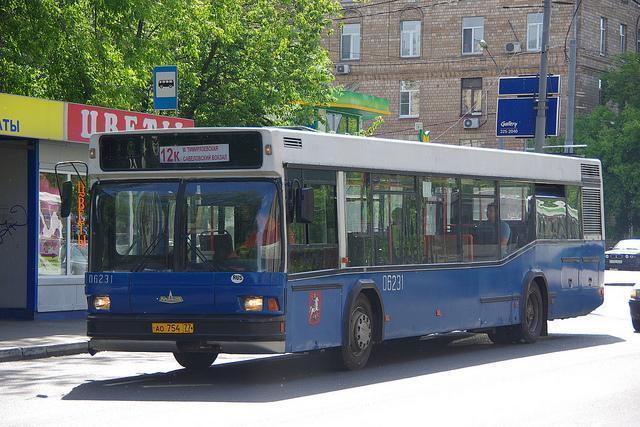How many wheels can you see on the bus?
Give a very brief answer. 4. How many buses are there?
Give a very brief answer. 1. How many tents in this image are to the left of the rainbow-colored umbrella at the end of the wooden walkway?
Give a very brief answer. 0. 